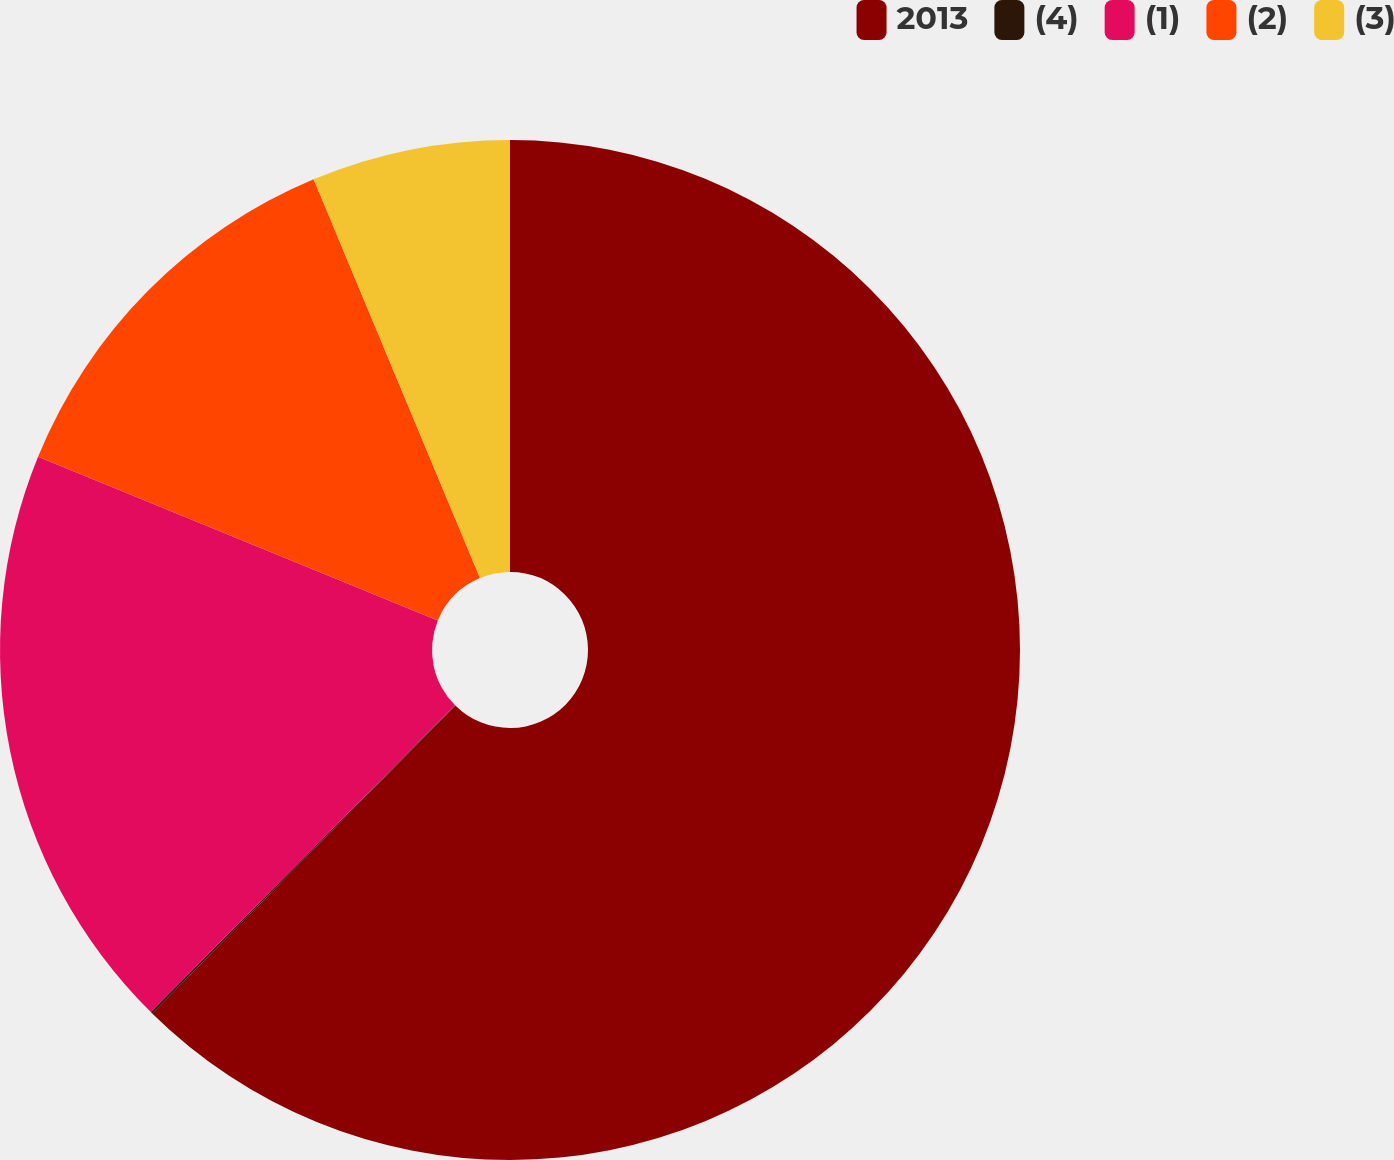Convert chart to OTSL. <chart><loc_0><loc_0><loc_500><loc_500><pie_chart><fcel>2013<fcel>(4)<fcel>(1)<fcel>(2)<fcel>(3)<nl><fcel>62.37%<fcel>0.06%<fcel>18.75%<fcel>12.52%<fcel>6.29%<nl></chart> 